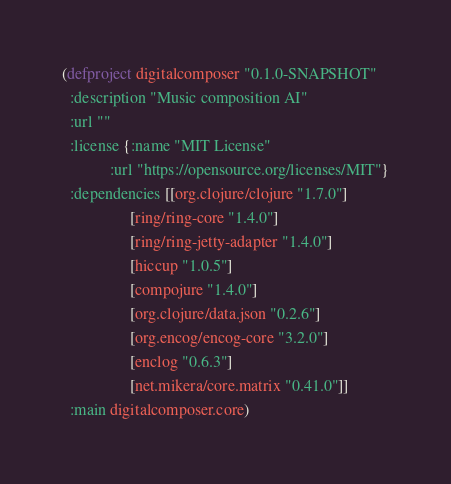<code> <loc_0><loc_0><loc_500><loc_500><_Clojure_>(defproject digitalcomposer "0.1.0-SNAPSHOT"
  :description "Music composition AI"
  :url ""
  :license {:name "MIT License"
            :url "https://opensource.org/licenses/MIT"}
  :dependencies [[org.clojure/clojure "1.7.0"]
                 [ring/ring-core "1.4.0"]
                 [ring/ring-jetty-adapter "1.4.0"]
                 [hiccup "1.0.5"]
                 [compojure "1.4.0"]
                 [org.clojure/data.json "0.2.6"]
                 [org.encog/encog-core "3.2.0"]
                 [enclog "0.6.3"]
                 [net.mikera/core.matrix "0.41.0"]]
  :main digitalcomposer.core)
</code> 